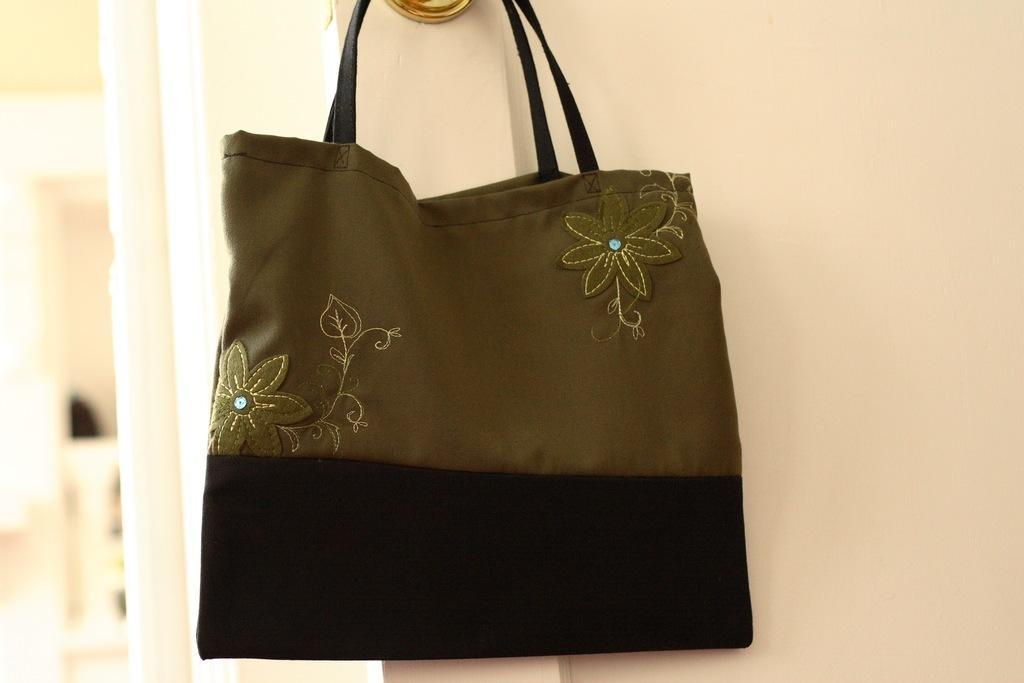Describe this image in one or two sentences. In this there is a hand bag which is in hanging position and the handbag has a flower design on it. 